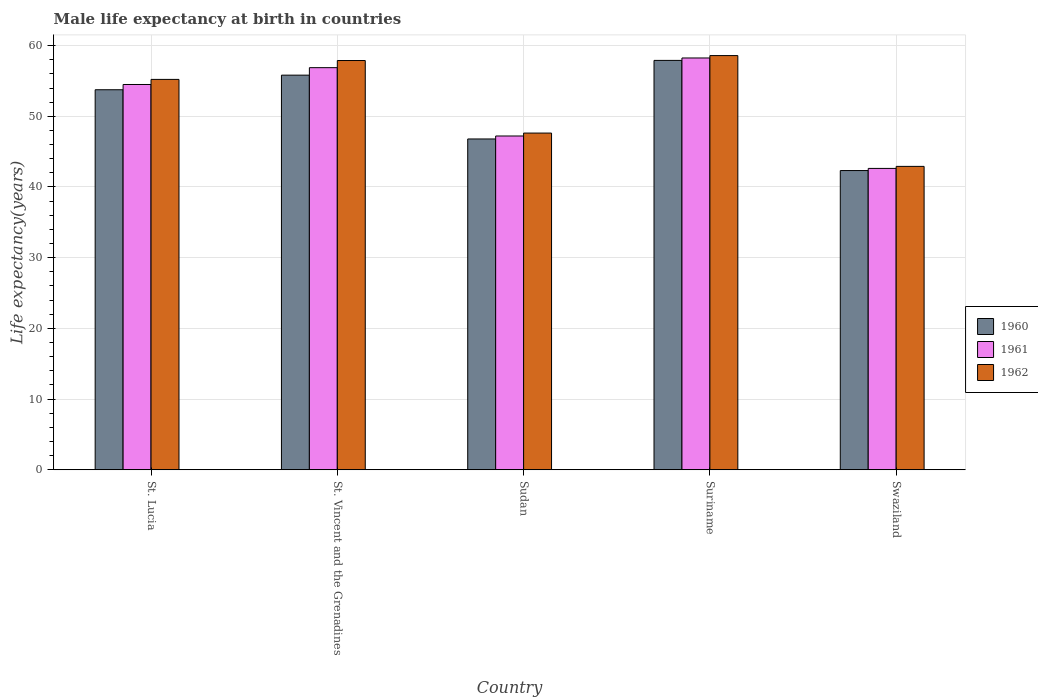Are the number of bars on each tick of the X-axis equal?
Your answer should be compact. Yes. How many bars are there on the 4th tick from the right?
Keep it short and to the point. 3. What is the label of the 5th group of bars from the left?
Provide a succinct answer. Swaziland. What is the male life expectancy at birth in 1960 in Suriname?
Your response must be concise. 57.91. Across all countries, what is the maximum male life expectancy at birth in 1962?
Provide a succinct answer. 58.59. Across all countries, what is the minimum male life expectancy at birth in 1961?
Offer a terse response. 42.63. In which country was the male life expectancy at birth in 1962 maximum?
Keep it short and to the point. Suriname. In which country was the male life expectancy at birth in 1961 minimum?
Keep it short and to the point. Swaziland. What is the total male life expectancy at birth in 1961 in the graph?
Your answer should be compact. 259.46. What is the difference between the male life expectancy at birth in 1960 in St. Vincent and the Grenadines and that in Swaziland?
Ensure brevity in your answer.  13.49. What is the difference between the male life expectancy at birth in 1961 in Sudan and the male life expectancy at birth in 1960 in Swaziland?
Your response must be concise. 4.89. What is the average male life expectancy at birth in 1962 per country?
Give a very brief answer. 52.45. What is the difference between the male life expectancy at birth of/in 1960 and male life expectancy at birth of/in 1962 in Suriname?
Your answer should be very brief. -0.68. In how many countries, is the male life expectancy at birth in 1962 greater than 40 years?
Provide a succinct answer. 5. What is the ratio of the male life expectancy at birth in 1961 in Sudan to that in Suriname?
Your response must be concise. 0.81. Is the male life expectancy at birth in 1961 in St. Lucia less than that in Swaziland?
Offer a very short reply. No. What is the difference between the highest and the second highest male life expectancy at birth in 1961?
Offer a terse response. -1.37. What is the difference between the highest and the lowest male life expectancy at birth in 1960?
Offer a very short reply. 15.58. What does the 3rd bar from the left in Sudan represents?
Ensure brevity in your answer.  1962. Is it the case that in every country, the sum of the male life expectancy at birth in 1961 and male life expectancy at birth in 1962 is greater than the male life expectancy at birth in 1960?
Your response must be concise. Yes. How many bars are there?
Provide a short and direct response. 15. How many countries are there in the graph?
Ensure brevity in your answer.  5. What is the difference between two consecutive major ticks on the Y-axis?
Make the answer very short. 10. How many legend labels are there?
Ensure brevity in your answer.  3. How are the legend labels stacked?
Give a very brief answer. Vertical. What is the title of the graph?
Ensure brevity in your answer.  Male life expectancy at birth in countries. Does "2014" appear as one of the legend labels in the graph?
Provide a short and direct response. No. What is the label or title of the X-axis?
Make the answer very short. Country. What is the label or title of the Y-axis?
Your answer should be compact. Life expectancy(years). What is the Life expectancy(years) of 1960 in St. Lucia?
Your response must be concise. 53.75. What is the Life expectancy(years) of 1961 in St. Lucia?
Give a very brief answer. 54.5. What is the Life expectancy(years) in 1962 in St. Lucia?
Your answer should be compact. 55.22. What is the Life expectancy(years) of 1960 in St. Vincent and the Grenadines?
Provide a succinct answer. 55.82. What is the Life expectancy(years) of 1961 in St. Vincent and the Grenadines?
Your answer should be compact. 56.88. What is the Life expectancy(years) in 1962 in St. Vincent and the Grenadines?
Offer a very short reply. 57.89. What is the Life expectancy(years) in 1960 in Sudan?
Your response must be concise. 46.79. What is the Life expectancy(years) in 1961 in Sudan?
Make the answer very short. 47.21. What is the Life expectancy(years) in 1962 in Sudan?
Offer a terse response. 47.63. What is the Life expectancy(years) of 1960 in Suriname?
Your answer should be very brief. 57.91. What is the Life expectancy(years) of 1961 in Suriname?
Keep it short and to the point. 58.25. What is the Life expectancy(years) of 1962 in Suriname?
Offer a very short reply. 58.59. What is the Life expectancy(years) of 1960 in Swaziland?
Your response must be concise. 42.33. What is the Life expectancy(years) in 1961 in Swaziland?
Your answer should be very brief. 42.63. What is the Life expectancy(years) in 1962 in Swaziland?
Provide a short and direct response. 42.92. Across all countries, what is the maximum Life expectancy(years) in 1960?
Provide a succinct answer. 57.91. Across all countries, what is the maximum Life expectancy(years) in 1961?
Your response must be concise. 58.25. Across all countries, what is the maximum Life expectancy(years) of 1962?
Make the answer very short. 58.59. Across all countries, what is the minimum Life expectancy(years) of 1960?
Offer a very short reply. 42.33. Across all countries, what is the minimum Life expectancy(years) in 1961?
Your answer should be very brief. 42.63. Across all countries, what is the minimum Life expectancy(years) in 1962?
Make the answer very short. 42.92. What is the total Life expectancy(years) in 1960 in the graph?
Your answer should be compact. 256.6. What is the total Life expectancy(years) in 1961 in the graph?
Offer a very short reply. 259.46. What is the total Life expectancy(years) of 1962 in the graph?
Offer a very short reply. 262.23. What is the difference between the Life expectancy(years) in 1960 in St. Lucia and that in St. Vincent and the Grenadines?
Offer a very short reply. -2.06. What is the difference between the Life expectancy(years) of 1961 in St. Lucia and that in St. Vincent and the Grenadines?
Your answer should be very brief. -2.38. What is the difference between the Life expectancy(years) of 1962 in St. Lucia and that in St. Vincent and the Grenadines?
Ensure brevity in your answer.  -2.67. What is the difference between the Life expectancy(years) in 1960 in St. Lucia and that in Sudan?
Make the answer very short. 6.96. What is the difference between the Life expectancy(years) of 1961 in St. Lucia and that in Sudan?
Provide a succinct answer. 7.29. What is the difference between the Life expectancy(years) of 1962 in St. Lucia and that in Sudan?
Your response must be concise. 7.59. What is the difference between the Life expectancy(years) of 1960 in St. Lucia and that in Suriname?
Provide a short and direct response. -4.15. What is the difference between the Life expectancy(years) in 1961 in St. Lucia and that in Suriname?
Your answer should be very brief. -3.75. What is the difference between the Life expectancy(years) of 1962 in St. Lucia and that in Suriname?
Give a very brief answer. -3.37. What is the difference between the Life expectancy(years) in 1960 in St. Lucia and that in Swaziland?
Your answer should be compact. 11.43. What is the difference between the Life expectancy(years) in 1961 in St. Lucia and that in Swaziland?
Provide a succinct answer. 11.87. What is the difference between the Life expectancy(years) of 1962 in St. Lucia and that in Swaziland?
Offer a very short reply. 12.3. What is the difference between the Life expectancy(years) in 1960 in St. Vincent and the Grenadines and that in Sudan?
Offer a terse response. 9.03. What is the difference between the Life expectancy(years) of 1961 in St. Vincent and the Grenadines and that in Sudan?
Your answer should be very brief. 9.66. What is the difference between the Life expectancy(years) in 1962 in St. Vincent and the Grenadines and that in Sudan?
Your answer should be very brief. 10.26. What is the difference between the Life expectancy(years) of 1960 in St. Vincent and the Grenadines and that in Suriname?
Make the answer very short. -2.09. What is the difference between the Life expectancy(years) of 1961 in St. Vincent and the Grenadines and that in Suriname?
Give a very brief answer. -1.37. What is the difference between the Life expectancy(years) in 1962 in St. Vincent and the Grenadines and that in Suriname?
Offer a very short reply. -0.7. What is the difference between the Life expectancy(years) in 1960 in St. Vincent and the Grenadines and that in Swaziland?
Your answer should be very brief. 13.49. What is the difference between the Life expectancy(years) in 1961 in St. Vincent and the Grenadines and that in Swaziland?
Provide a short and direct response. 14.25. What is the difference between the Life expectancy(years) in 1962 in St. Vincent and the Grenadines and that in Swaziland?
Keep it short and to the point. 14.97. What is the difference between the Life expectancy(years) in 1960 in Sudan and that in Suriname?
Offer a very short reply. -11.11. What is the difference between the Life expectancy(years) of 1961 in Sudan and that in Suriname?
Your answer should be very brief. -11.03. What is the difference between the Life expectancy(years) of 1962 in Sudan and that in Suriname?
Make the answer very short. -10.96. What is the difference between the Life expectancy(years) in 1960 in Sudan and that in Swaziland?
Provide a succinct answer. 4.47. What is the difference between the Life expectancy(years) of 1961 in Sudan and that in Swaziland?
Your answer should be compact. 4.59. What is the difference between the Life expectancy(years) in 1962 in Sudan and that in Swaziland?
Provide a succinct answer. 4.71. What is the difference between the Life expectancy(years) in 1960 in Suriname and that in Swaziland?
Your answer should be very brief. 15.58. What is the difference between the Life expectancy(years) of 1961 in Suriname and that in Swaziland?
Provide a succinct answer. 15.62. What is the difference between the Life expectancy(years) in 1962 in Suriname and that in Swaziland?
Offer a terse response. 15.67. What is the difference between the Life expectancy(years) of 1960 in St. Lucia and the Life expectancy(years) of 1961 in St. Vincent and the Grenadines?
Your answer should be compact. -3.12. What is the difference between the Life expectancy(years) in 1960 in St. Lucia and the Life expectancy(years) in 1962 in St. Vincent and the Grenadines?
Your answer should be very brief. -4.13. What is the difference between the Life expectancy(years) of 1961 in St. Lucia and the Life expectancy(years) of 1962 in St. Vincent and the Grenadines?
Keep it short and to the point. -3.39. What is the difference between the Life expectancy(years) of 1960 in St. Lucia and the Life expectancy(years) of 1961 in Sudan?
Your answer should be compact. 6.54. What is the difference between the Life expectancy(years) of 1960 in St. Lucia and the Life expectancy(years) of 1962 in Sudan?
Give a very brief answer. 6.13. What is the difference between the Life expectancy(years) in 1961 in St. Lucia and the Life expectancy(years) in 1962 in Sudan?
Ensure brevity in your answer.  6.87. What is the difference between the Life expectancy(years) of 1960 in St. Lucia and the Life expectancy(years) of 1961 in Suriname?
Your answer should be very brief. -4.49. What is the difference between the Life expectancy(years) in 1960 in St. Lucia and the Life expectancy(years) in 1962 in Suriname?
Provide a short and direct response. -4.83. What is the difference between the Life expectancy(years) in 1961 in St. Lucia and the Life expectancy(years) in 1962 in Suriname?
Your answer should be compact. -4.09. What is the difference between the Life expectancy(years) in 1960 in St. Lucia and the Life expectancy(years) in 1961 in Swaziland?
Provide a short and direct response. 11.13. What is the difference between the Life expectancy(years) in 1960 in St. Lucia and the Life expectancy(years) in 1962 in Swaziland?
Your answer should be compact. 10.84. What is the difference between the Life expectancy(years) of 1961 in St. Lucia and the Life expectancy(years) of 1962 in Swaziland?
Your answer should be very brief. 11.58. What is the difference between the Life expectancy(years) of 1960 in St. Vincent and the Grenadines and the Life expectancy(years) of 1961 in Sudan?
Provide a succinct answer. 8.61. What is the difference between the Life expectancy(years) of 1960 in St. Vincent and the Grenadines and the Life expectancy(years) of 1962 in Sudan?
Give a very brief answer. 8.19. What is the difference between the Life expectancy(years) in 1961 in St. Vincent and the Grenadines and the Life expectancy(years) in 1962 in Sudan?
Your answer should be very brief. 9.25. What is the difference between the Life expectancy(years) of 1960 in St. Vincent and the Grenadines and the Life expectancy(years) of 1961 in Suriname?
Give a very brief answer. -2.43. What is the difference between the Life expectancy(years) of 1960 in St. Vincent and the Grenadines and the Life expectancy(years) of 1962 in Suriname?
Your response must be concise. -2.77. What is the difference between the Life expectancy(years) of 1961 in St. Vincent and the Grenadines and the Life expectancy(years) of 1962 in Suriname?
Your response must be concise. -1.71. What is the difference between the Life expectancy(years) of 1960 in St. Vincent and the Grenadines and the Life expectancy(years) of 1961 in Swaziland?
Your answer should be very brief. 13.19. What is the difference between the Life expectancy(years) of 1960 in St. Vincent and the Grenadines and the Life expectancy(years) of 1962 in Swaziland?
Keep it short and to the point. 12.9. What is the difference between the Life expectancy(years) in 1961 in St. Vincent and the Grenadines and the Life expectancy(years) in 1962 in Swaziland?
Offer a terse response. 13.96. What is the difference between the Life expectancy(years) in 1960 in Sudan and the Life expectancy(years) in 1961 in Suriname?
Your answer should be very brief. -11.45. What is the difference between the Life expectancy(years) of 1960 in Sudan and the Life expectancy(years) of 1962 in Suriname?
Provide a short and direct response. -11.79. What is the difference between the Life expectancy(years) in 1961 in Sudan and the Life expectancy(years) in 1962 in Suriname?
Give a very brief answer. -11.37. What is the difference between the Life expectancy(years) of 1960 in Sudan and the Life expectancy(years) of 1961 in Swaziland?
Provide a succinct answer. 4.17. What is the difference between the Life expectancy(years) of 1960 in Sudan and the Life expectancy(years) of 1962 in Swaziland?
Give a very brief answer. 3.88. What is the difference between the Life expectancy(years) in 1961 in Sudan and the Life expectancy(years) in 1962 in Swaziland?
Ensure brevity in your answer.  4.3. What is the difference between the Life expectancy(years) of 1960 in Suriname and the Life expectancy(years) of 1961 in Swaziland?
Offer a very short reply. 15.28. What is the difference between the Life expectancy(years) of 1960 in Suriname and the Life expectancy(years) of 1962 in Swaziland?
Make the answer very short. 14.99. What is the difference between the Life expectancy(years) in 1961 in Suriname and the Life expectancy(years) in 1962 in Swaziland?
Provide a succinct answer. 15.33. What is the average Life expectancy(years) of 1960 per country?
Your answer should be compact. 51.32. What is the average Life expectancy(years) of 1961 per country?
Your response must be concise. 51.89. What is the average Life expectancy(years) of 1962 per country?
Make the answer very short. 52.45. What is the difference between the Life expectancy(years) of 1960 and Life expectancy(years) of 1961 in St. Lucia?
Your response must be concise. -0.74. What is the difference between the Life expectancy(years) in 1960 and Life expectancy(years) in 1962 in St. Lucia?
Keep it short and to the point. -1.46. What is the difference between the Life expectancy(years) of 1961 and Life expectancy(years) of 1962 in St. Lucia?
Offer a very short reply. -0.72. What is the difference between the Life expectancy(years) in 1960 and Life expectancy(years) in 1961 in St. Vincent and the Grenadines?
Offer a terse response. -1.06. What is the difference between the Life expectancy(years) in 1960 and Life expectancy(years) in 1962 in St. Vincent and the Grenadines?
Keep it short and to the point. -2.07. What is the difference between the Life expectancy(years) of 1961 and Life expectancy(years) of 1962 in St. Vincent and the Grenadines?
Offer a very short reply. -1.01. What is the difference between the Life expectancy(years) of 1960 and Life expectancy(years) of 1961 in Sudan?
Your response must be concise. -0.42. What is the difference between the Life expectancy(years) of 1960 and Life expectancy(years) of 1962 in Sudan?
Give a very brief answer. -0.83. What is the difference between the Life expectancy(years) in 1961 and Life expectancy(years) in 1962 in Sudan?
Offer a very short reply. -0.41. What is the difference between the Life expectancy(years) in 1960 and Life expectancy(years) in 1961 in Suriname?
Keep it short and to the point. -0.34. What is the difference between the Life expectancy(years) of 1960 and Life expectancy(years) of 1962 in Suriname?
Offer a very short reply. -0.68. What is the difference between the Life expectancy(years) in 1961 and Life expectancy(years) in 1962 in Suriname?
Ensure brevity in your answer.  -0.34. What is the difference between the Life expectancy(years) of 1960 and Life expectancy(years) of 1961 in Swaziland?
Your answer should be compact. -0.3. What is the difference between the Life expectancy(years) of 1960 and Life expectancy(years) of 1962 in Swaziland?
Provide a succinct answer. -0.59. What is the difference between the Life expectancy(years) of 1961 and Life expectancy(years) of 1962 in Swaziland?
Your response must be concise. -0.29. What is the ratio of the Life expectancy(years) of 1961 in St. Lucia to that in St. Vincent and the Grenadines?
Provide a short and direct response. 0.96. What is the ratio of the Life expectancy(years) in 1962 in St. Lucia to that in St. Vincent and the Grenadines?
Your answer should be very brief. 0.95. What is the ratio of the Life expectancy(years) of 1960 in St. Lucia to that in Sudan?
Offer a very short reply. 1.15. What is the ratio of the Life expectancy(years) in 1961 in St. Lucia to that in Sudan?
Make the answer very short. 1.15. What is the ratio of the Life expectancy(years) of 1962 in St. Lucia to that in Sudan?
Give a very brief answer. 1.16. What is the ratio of the Life expectancy(years) in 1960 in St. Lucia to that in Suriname?
Your answer should be very brief. 0.93. What is the ratio of the Life expectancy(years) in 1961 in St. Lucia to that in Suriname?
Make the answer very short. 0.94. What is the ratio of the Life expectancy(years) in 1962 in St. Lucia to that in Suriname?
Keep it short and to the point. 0.94. What is the ratio of the Life expectancy(years) of 1960 in St. Lucia to that in Swaziland?
Keep it short and to the point. 1.27. What is the ratio of the Life expectancy(years) of 1961 in St. Lucia to that in Swaziland?
Provide a short and direct response. 1.28. What is the ratio of the Life expectancy(years) of 1962 in St. Lucia to that in Swaziland?
Provide a short and direct response. 1.29. What is the ratio of the Life expectancy(years) of 1960 in St. Vincent and the Grenadines to that in Sudan?
Give a very brief answer. 1.19. What is the ratio of the Life expectancy(years) of 1961 in St. Vincent and the Grenadines to that in Sudan?
Your answer should be compact. 1.2. What is the ratio of the Life expectancy(years) of 1962 in St. Vincent and the Grenadines to that in Sudan?
Offer a very short reply. 1.22. What is the ratio of the Life expectancy(years) of 1961 in St. Vincent and the Grenadines to that in Suriname?
Provide a short and direct response. 0.98. What is the ratio of the Life expectancy(years) in 1962 in St. Vincent and the Grenadines to that in Suriname?
Your response must be concise. 0.99. What is the ratio of the Life expectancy(years) in 1960 in St. Vincent and the Grenadines to that in Swaziland?
Your response must be concise. 1.32. What is the ratio of the Life expectancy(years) of 1961 in St. Vincent and the Grenadines to that in Swaziland?
Offer a very short reply. 1.33. What is the ratio of the Life expectancy(years) in 1962 in St. Vincent and the Grenadines to that in Swaziland?
Keep it short and to the point. 1.35. What is the ratio of the Life expectancy(years) of 1960 in Sudan to that in Suriname?
Ensure brevity in your answer.  0.81. What is the ratio of the Life expectancy(years) of 1961 in Sudan to that in Suriname?
Provide a succinct answer. 0.81. What is the ratio of the Life expectancy(years) in 1962 in Sudan to that in Suriname?
Your answer should be very brief. 0.81. What is the ratio of the Life expectancy(years) in 1960 in Sudan to that in Swaziland?
Provide a succinct answer. 1.11. What is the ratio of the Life expectancy(years) in 1961 in Sudan to that in Swaziland?
Make the answer very short. 1.11. What is the ratio of the Life expectancy(years) of 1962 in Sudan to that in Swaziland?
Your answer should be compact. 1.11. What is the ratio of the Life expectancy(years) of 1960 in Suriname to that in Swaziland?
Make the answer very short. 1.37. What is the ratio of the Life expectancy(years) of 1961 in Suriname to that in Swaziland?
Your answer should be compact. 1.37. What is the ratio of the Life expectancy(years) of 1962 in Suriname to that in Swaziland?
Provide a succinct answer. 1.37. What is the difference between the highest and the second highest Life expectancy(years) of 1960?
Your answer should be compact. 2.09. What is the difference between the highest and the second highest Life expectancy(years) of 1961?
Your response must be concise. 1.37. What is the difference between the highest and the second highest Life expectancy(years) of 1962?
Offer a terse response. 0.7. What is the difference between the highest and the lowest Life expectancy(years) in 1960?
Your answer should be very brief. 15.58. What is the difference between the highest and the lowest Life expectancy(years) of 1961?
Offer a terse response. 15.62. What is the difference between the highest and the lowest Life expectancy(years) in 1962?
Provide a short and direct response. 15.67. 